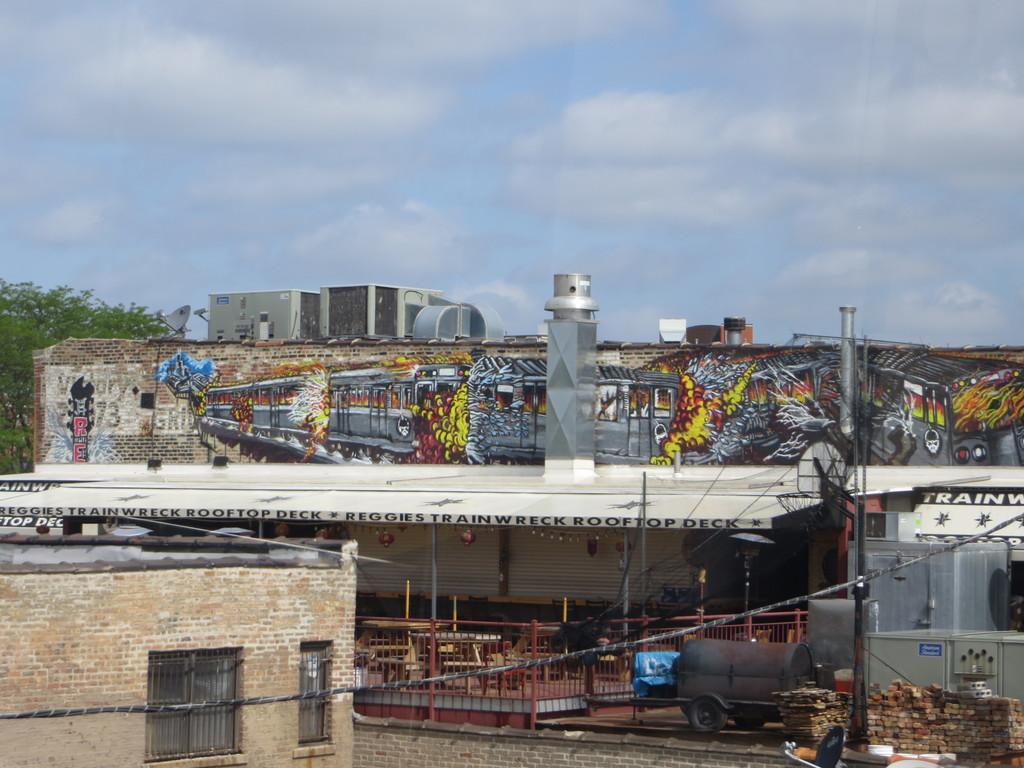Can you describe this image briefly? This is a picture which consists of buildings, current poles, cables, trees and other objects. In the middle it is looking like a shed and there are vehicles. At the top it is sky. On the walls of the building we can see graffiti. 